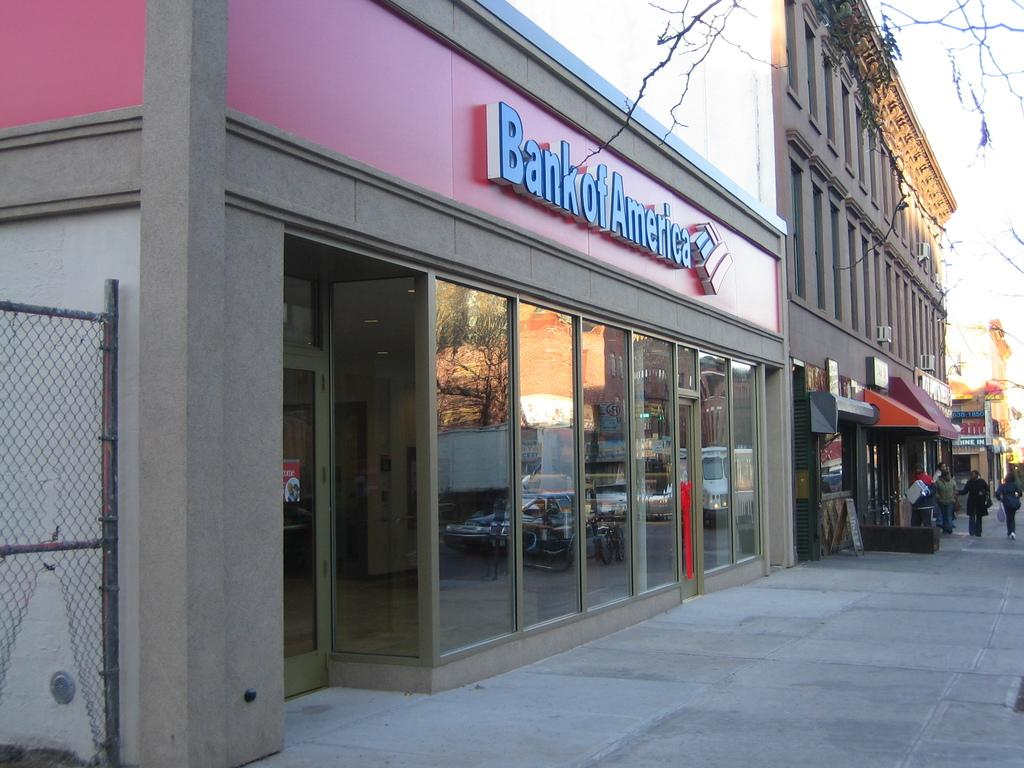Provide a one-sentence caption for the provided image. The front of a Bank of America branch. 